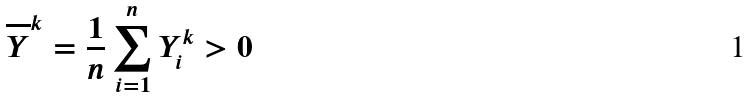Convert formula to latex. <formula><loc_0><loc_0><loc_500><loc_500>\overline { Y } ^ { k } = \frac { 1 } { n } \sum _ { i = 1 } ^ { n } Y _ { i } ^ { k } > 0</formula> 